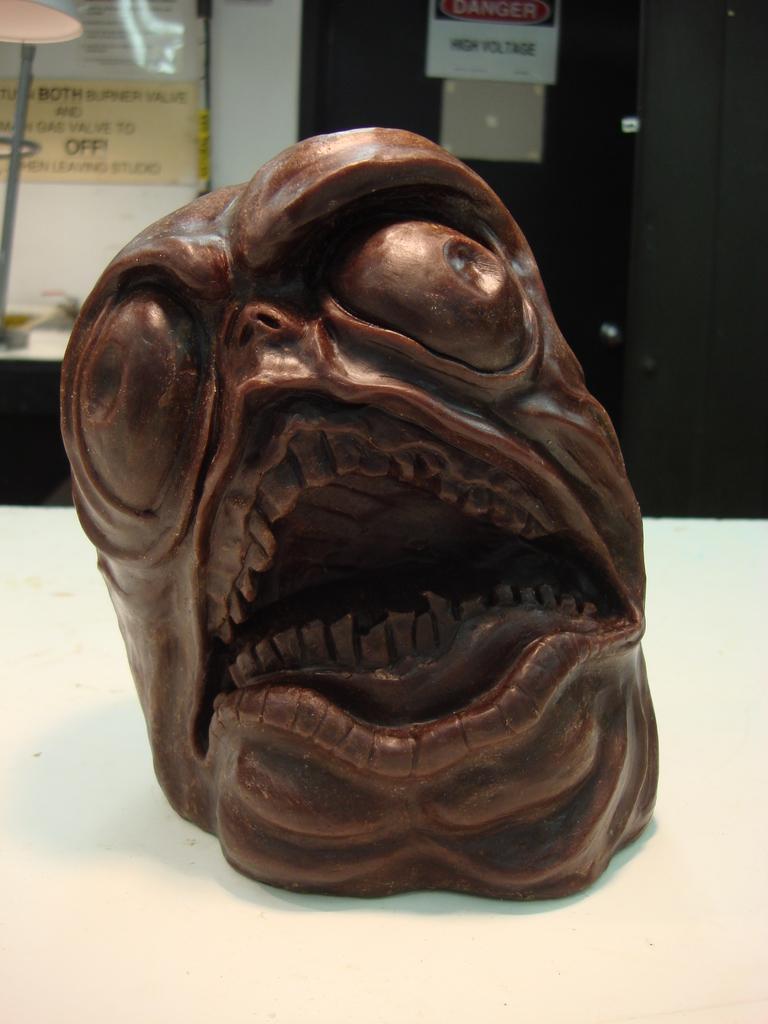Could you give a brief overview of what you see in this image? In this image we can see a sculpture on the table. There are few posters in the image. We can see some text on the posters. 